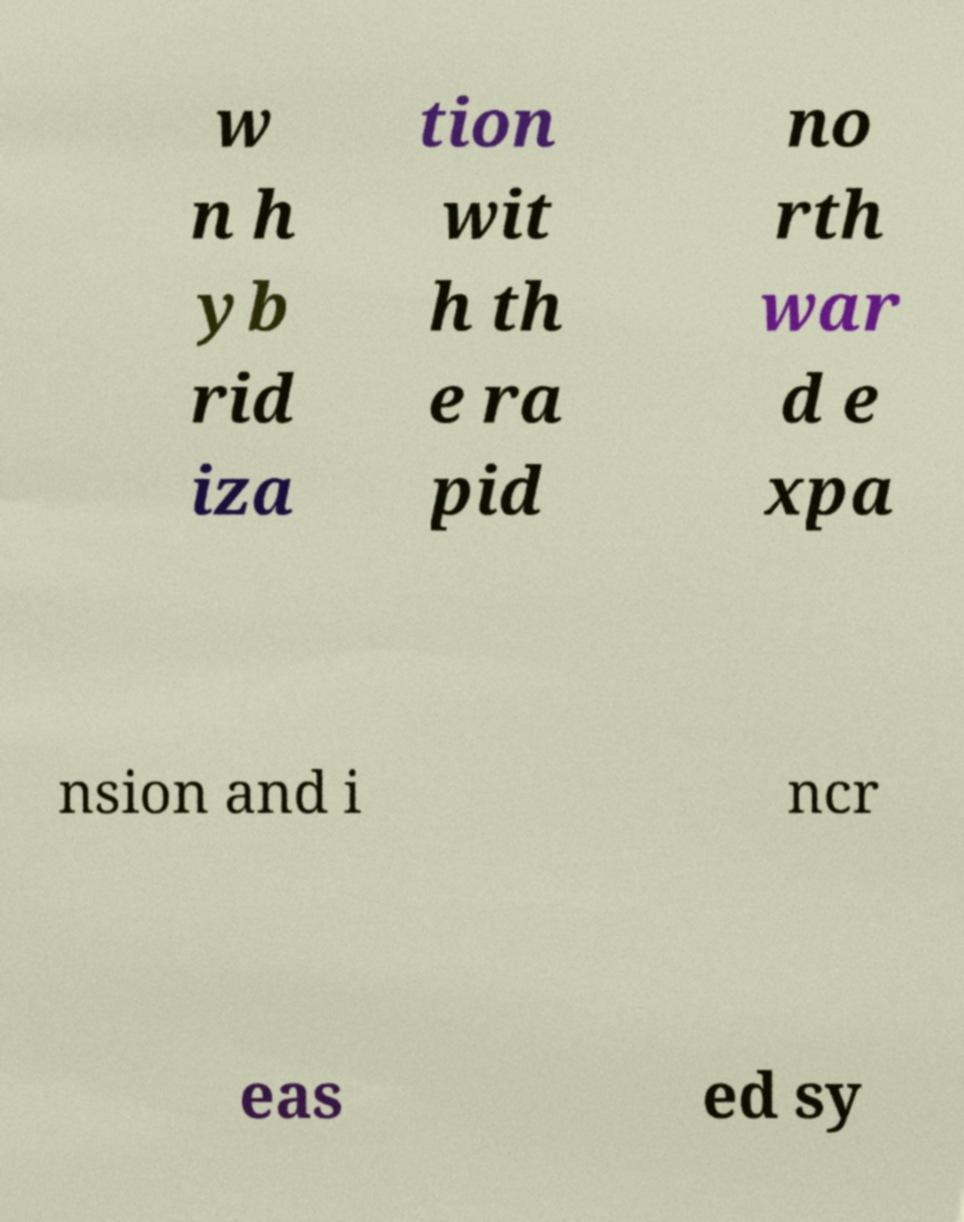For documentation purposes, I need the text within this image transcribed. Could you provide that? w n h yb rid iza tion wit h th e ra pid no rth war d e xpa nsion and i ncr eas ed sy 